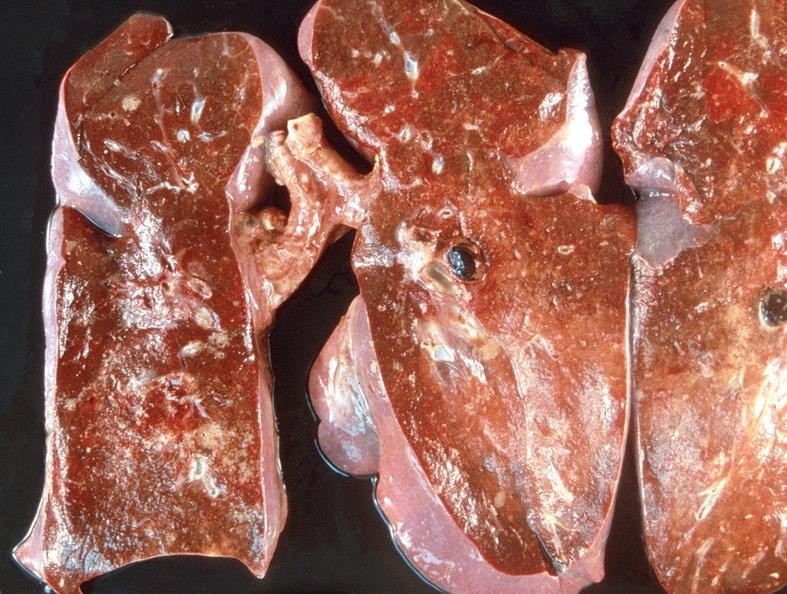does this image show pulmonary thromboemboli?
Answer the question using a single word or phrase. Yes 